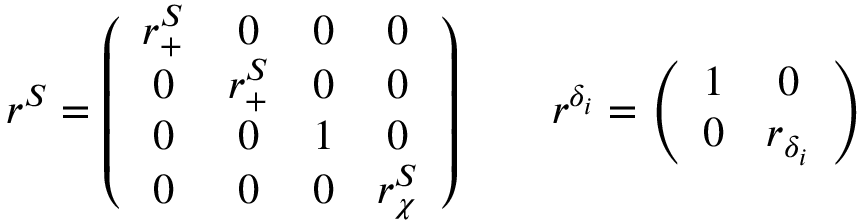<formula> <loc_0><loc_0><loc_500><loc_500>r ^ { S } = \left ( \begin{array} { c c c c } { { r _ { + } ^ { S } } } & { 0 } & { 0 } & { 0 } \\ { 0 } & { { r _ { + } ^ { S } } } & { 0 } & { 0 } \\ { 0 } & { 0 } & { 1 } & { 0 } \\ { 0 } & { 0 } & { 0 } & { { r _ { \chi } ^ { S } } } \end{array} \right ) \quad r ^ { \delta _ { i } } = \left ( \begin{array} { c c } { 1 } & { 0 } \\ { 0 } & { { r _ { \delta _ { i } } } } \end{array} \right )</formula> 